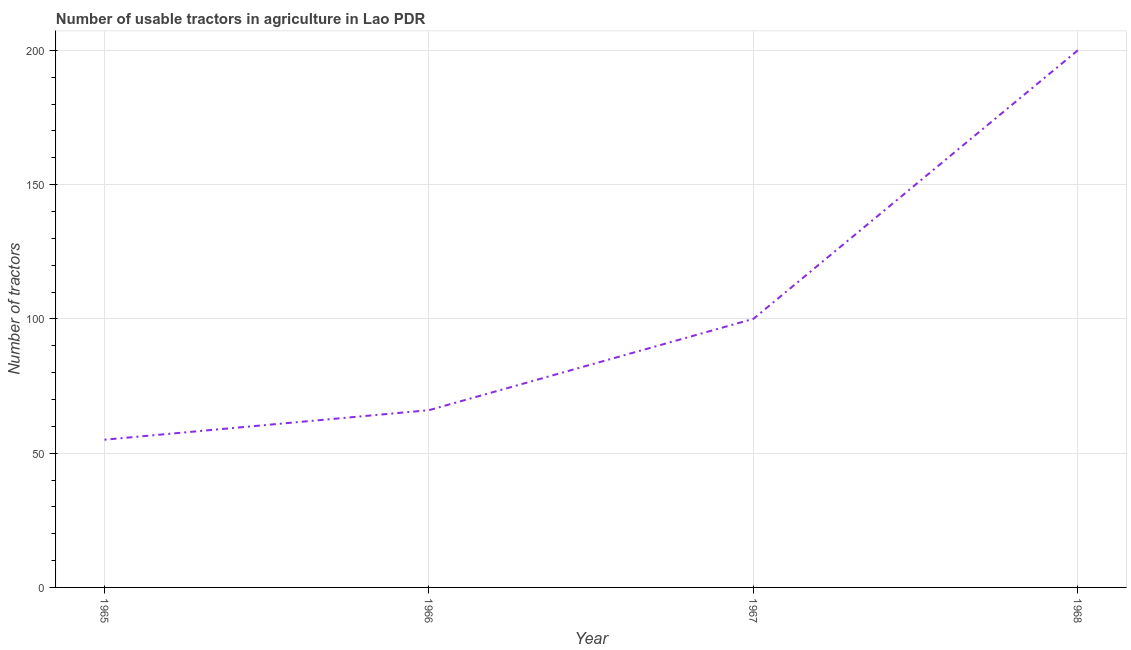What is the number of tractors in 1965?
Offer a terse response. 55. Across all years, what is the maximum number of tractors?
Your answer should be compact. 200. Across all years, what is the minimum number of tractors?
Give a very brief answer. 55. In which year was the number of tractors maximum?
Keep it short and to the point. 1968. In which year was the number of tractors minimum?
Offer a very short reply. 1965. What is the sum of the number of tractors?
Provide a succinct answer. 421. What is the difference between the number of tractors in 1966 and 1968?
Your answer should be very brief. -134. What is the average number of tractors per year?
Your answer should be very brief. 105.25. In how many years, is the number of tractors greater than 100 ?
Provide a short and direct response. 1. Do a majority of the years between 1966 and 1968 (inclusive) have number of tractors greater than 60 ?
Ensure brevity in your answer.  Yes. What is the ratio of the number of tractors in 1967 to that in 1968?
Ensure brevity in your answer.  0.5. Is the number of tractors in 1967 less than that in 1968?
Your answer should be very brief. Yes. Is the difference between the number of tractors in 1965 and 1968 greater than the difference between any two years?
Ensure brevity in your answer.  Yes. What is the difference between the highest and the second highest number of tractors?
Offer a very short reply. 100. Is the sum of the number of tractors in 1967 and 1968 greater than the maximum number of tractors across all years?
Provide a succinct answer. Yes. What is the difference between the highest and the lowest number of tractors?
Ensure brevity in your answer.  145. How many lines are there?
Keep it short and to the point. 1. How many years are there in the graph?
Your response must be concise. 4. Does the graph contain any zero values?
Your response must be concise. No. Does the graph contain grids?
Provide a succinct answer. Yes. What is the title of the graph?
Offer a terse response. Number of usable tractors in agriculture in Lao PDR. What is the label or title of the Y-axis?
Give a very brief answer. Number of tractors. What is the Number of tractors of 1967?
Offer a very short reply. 100. What is the difference between the Number of tractors in 1965 and 1967?
Your answer should be compact. -45. What is the difference between the Number of tractors in 1965 and 1968?
Give a very brief answer. -145. What is the difference between the Number of tractors in 1966 and 1967?
Your response must be concise. -34. What is the difference between the Number of tractors in 1966 and 1968?
Ensure brevity in your answer.  -134. What is the difference between the Number of tractors in 1967 and 1968?
Provide a succinct answer. -100. What is the ratio of the Number of tractors in 1965 to that in 1966?
Your answer should be compact. 0.83. What is the ratio of the Number of tractors in 1965 to that in 1967?
Provide a succinct answer. 0.55. What is the ratio of the Number of tractors in 1965 to that in 1968?
Your answer should be very brief. 0.28. What is the ratio of the Number of tractors in 1966 to that in 1967?
Keep it short and to the point. 0.66. What is the ratio of the Number of tractors in 1966 to that in 1968?
Provide a short and direct response. 0.33. What is the ratio of the Number of tractors in 1967 to that in 1968?
Your response must be concise. 0.5. 